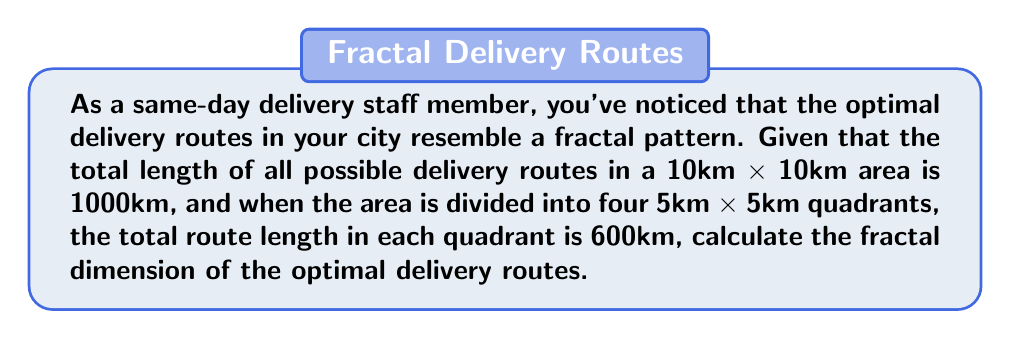Provide a solution to this math problem. To calculate the fractal dimension, we'll use the box-counting method:

1. Define the scaling factor:
   The area is divided into 4 equal parts, so the scaling factor is:
   $$ s = \frac{1}{2} $$

2. Define the number of self-similar pieces:
   Each quadrant contains 600km of routes, so the number of self-similar pieces is:
   $$ N = \frac{600 \text{ km}}{1000 \text{ km}} \times 4 = 2.4 $$

3. Use the fractal dimension formula:
   $$ D = \frac{\log N}{\log(\frac{1}{s})} $$

4. Substitute the values:
   $$ D = \frac{\log 2.4}{\log 2} $$

5. Calculate:
   $$ D = \frac{0.380211242}{0.301029996} \approx 1.26305 $$

The fractal dimension is approximately 1.26305, which is between 1 (a line) and 2 (a plane), indicating a complex, fractal-like structure of the delivery routes.
Answer: $D \approx 1.26305$ 